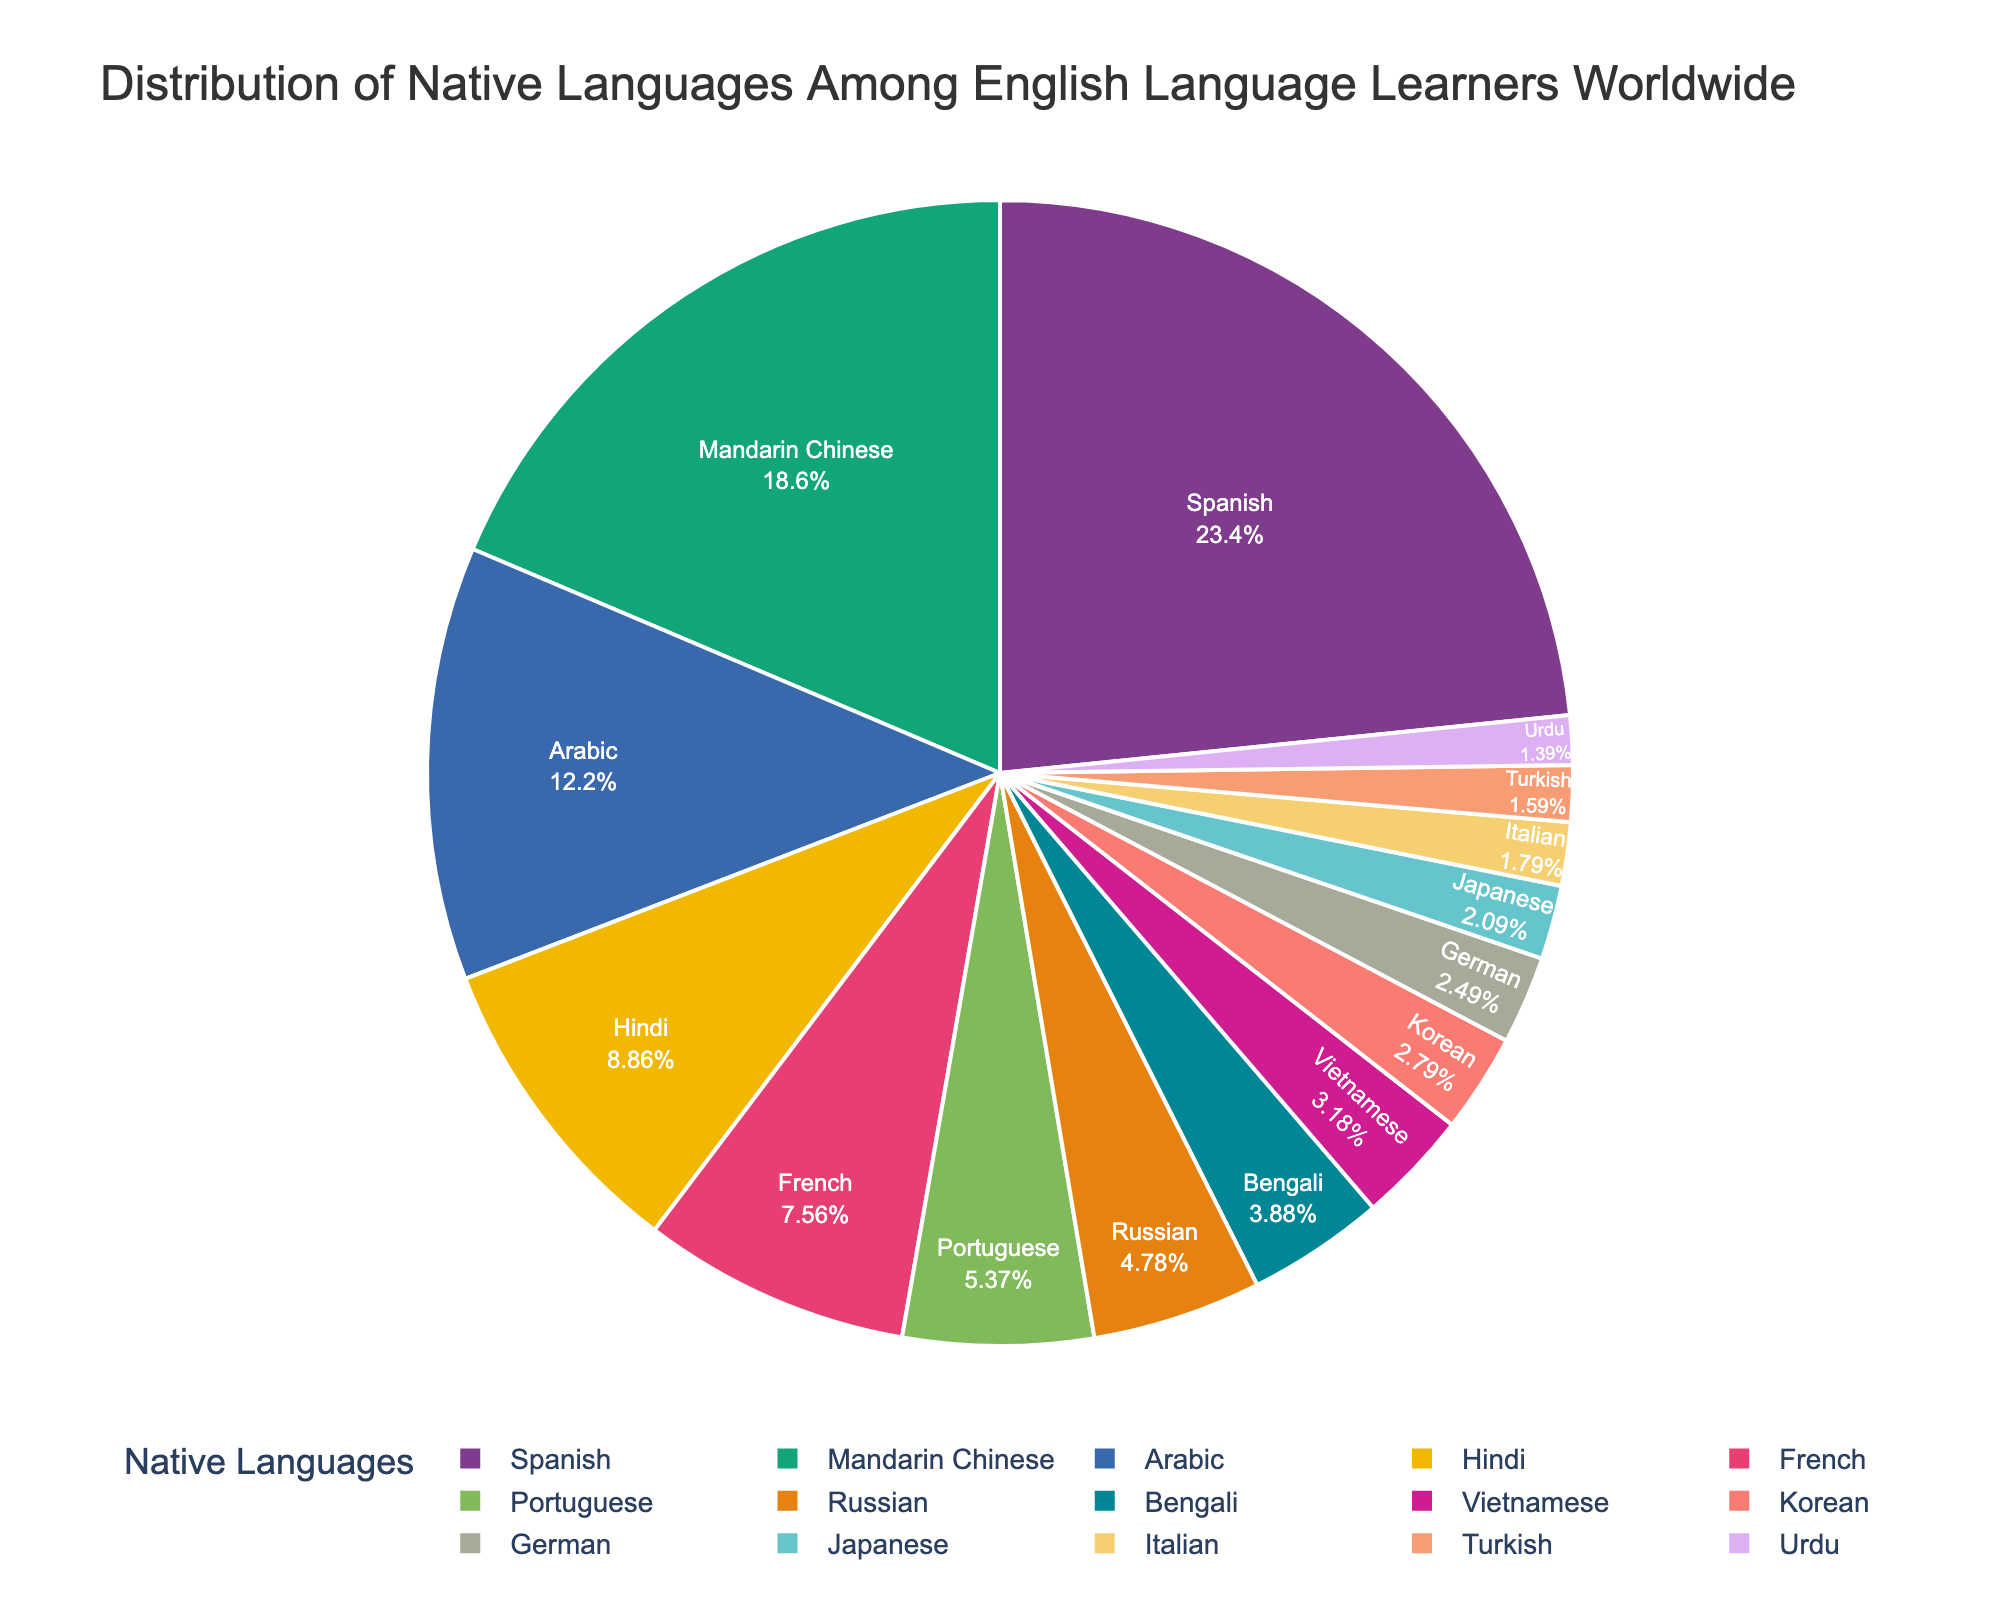What percentage of English language learners have Spanish as their native language? By referring to the figure, we can directly identify the percentage corresponding to Spanish among all the native languages of English language learners.
Answer: 23.5% Which native language has a higher percentage of learners than French but lower than Arabic? First, locate the percentages for French (7.6%) and Arabic (12.3%). The language that falls between these two percentages on the chart is Hindi (8.9%).
Answer: Hindi What is the combined percentage of English learners with Mandarin Chinese and Portuguese as their native languages? Locate the percentages for Mandarin Chinese (18.7%) and Portuguese (5.4%). Adding them together, we get 18.7% + 5.4% = 24.1%.
Answer: 24.1% Which native language has the smallest percentage among English language learners, and what is the percentage? By examining the figure, find the language slice with the smallest proportion. This is Urdu with 1.4%.
Answer: Urdu, 1.4% Is the percentage of learners with Bengali as their native language larger than those with Korean as their native language? Compare the percentages for Bengali (3.9%) and Korean (2.8%). Bengali's percentage is larger.
Answer: Yes Which native languages have nearly the same percentage of learners, and what are those percentages? Scanning the figure for percentages that look similar, German (2.5%) and Japanese (2.1%) are the closest, with a difference of 0.4%.
Answer: German (2.5%) and Japanese (2.1%) How many native languages have more than 5% of English language learners? Identify the sections with percentages greater than 5%. They are Spanish (23.5%), Mandarin Chinese (18.7%), Arabic (12.3%), Hindi (8.9%), French (7.6%), and Portuguese (5.4%). There are 6 languages.
Answer: 6 What is the difference in the percentage of learners between Turkish and Italian as their native languages? Find the percentages: Italian (1.8%) and Turkish (1.6%). Subtract the smaller percentage from the larger one: 1.8% - 1.6% = 0.2%.
Answer: 0.2% Which language has more learners, Vietnamese or Bengali, and by how much? Locate the percentages for Vietnamese (3.2%) and Bengali (3.9%). Bengali has more learners. The difference is 3.9% - 3.2% = 0.7%.
Answer: Bengali by 0.7% 